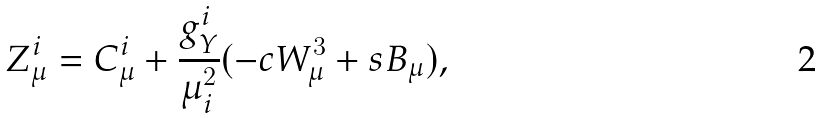<formula> <loc_0><loc_0><loc_500><loc_500>Z ^ { i } _ { \mu } = C _ { \mu } ^ { i } + \frac { g _ { Y } ^ { i } } { \mu _ { i } ^ { 2 } } ( - c W _ { \mu } ^ { 3 } + s B _ { \mu } ) ,</formula> 